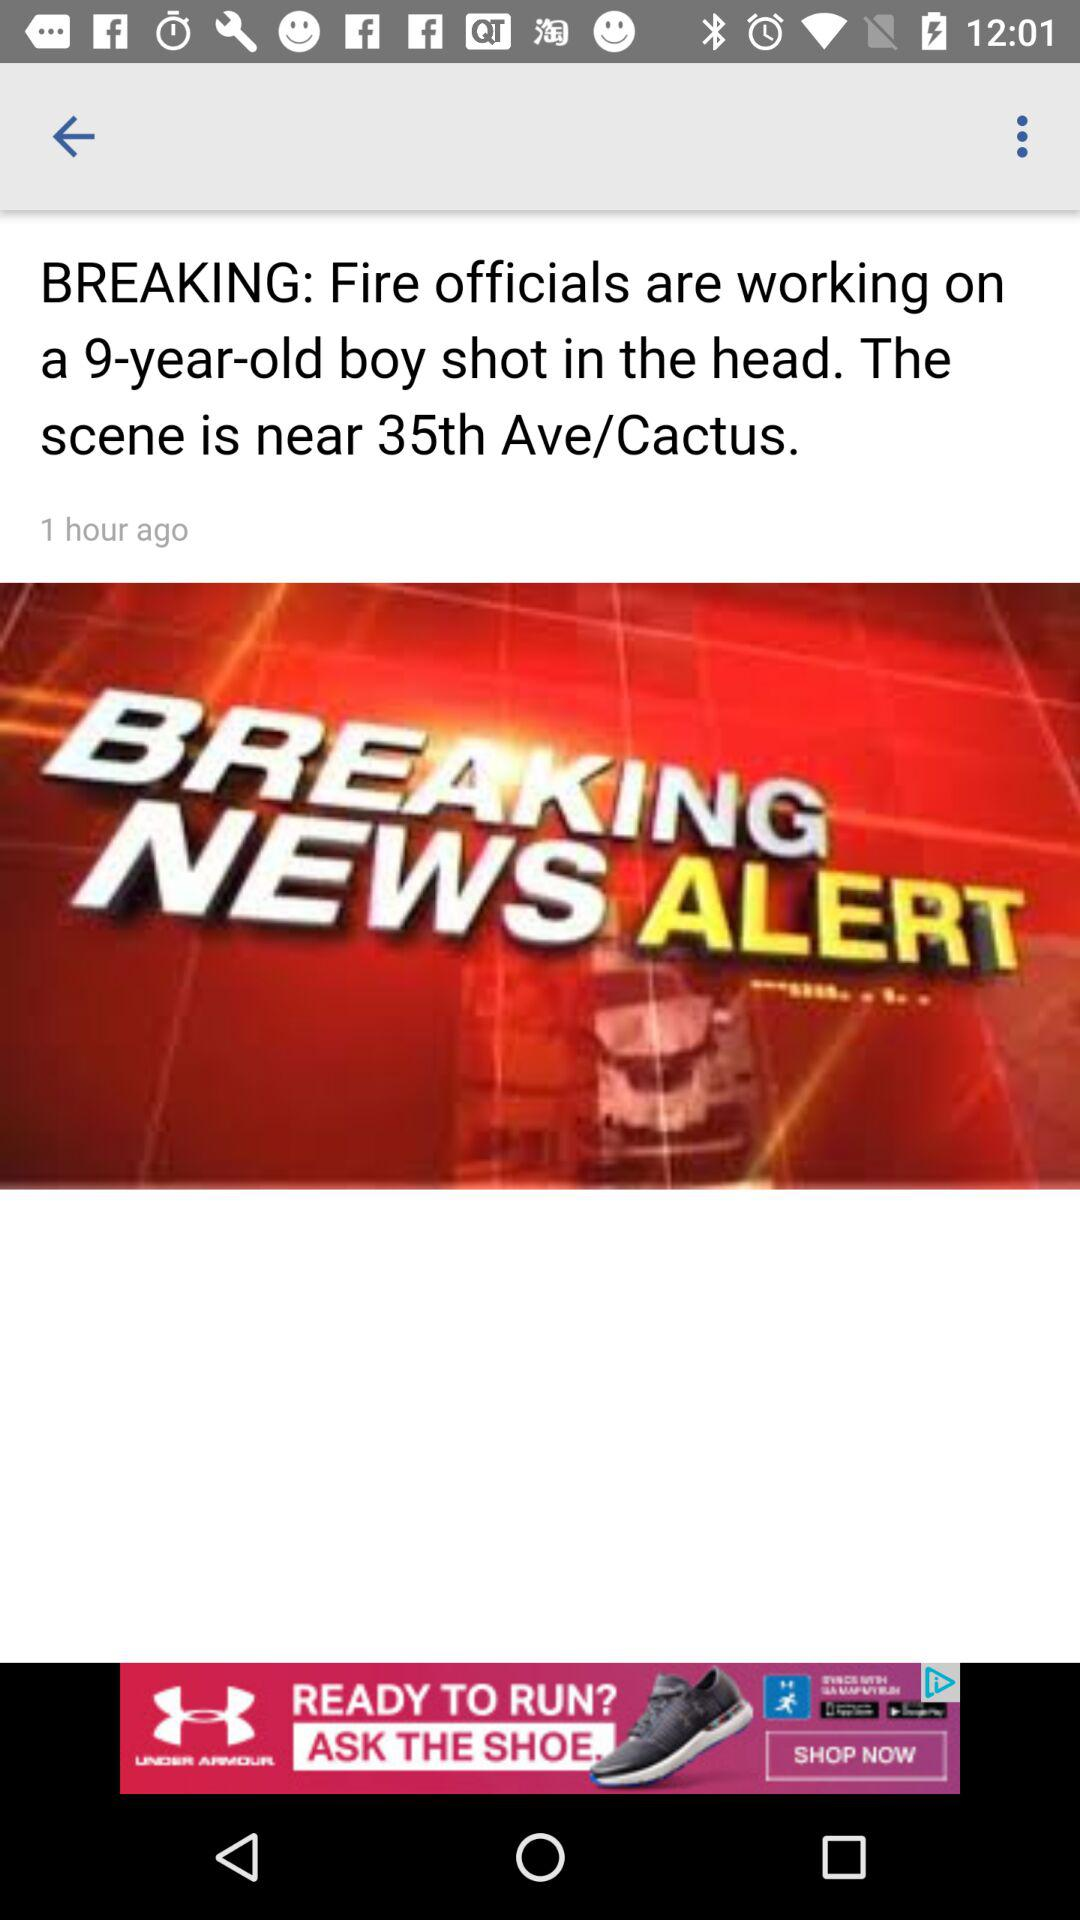How many hours ago was the news updated? The news was updated 1 hour ago. 